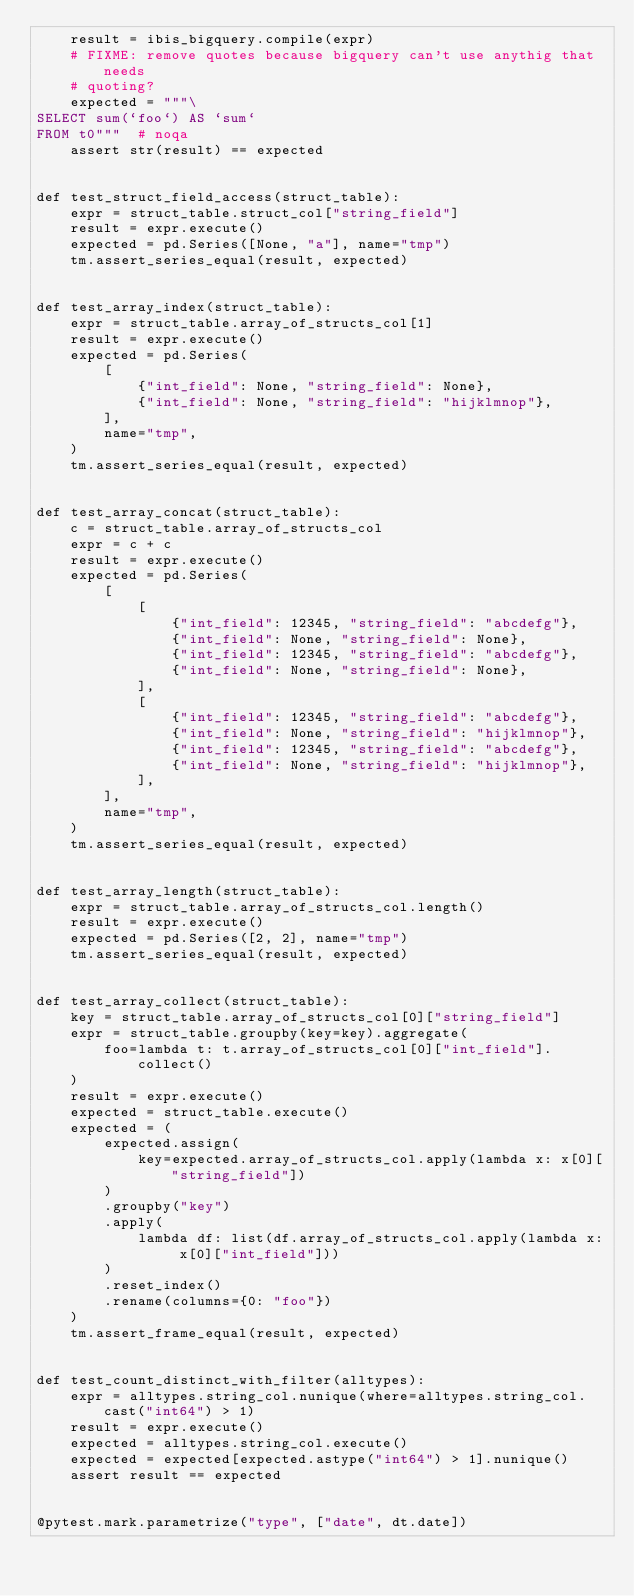Convert code to text. <code><loc_0><loc_0><loc_500><loc_500><_Python_>    result = ibis_bigquery.compile(expr)
    # FIXME: remove quotes because bigquery can't use anythig that needs
    # quoting?
    expected = """\
SELECT sum(`foo`) AS `sum`
FROM t0"""  # noqa
    assert str(result) == expected


def test_struct_field_access(struct_table):
    expr = struct_table.struct_col["string_field"]
    result = expr.execute()
    expected = pd.Series([None, "a"], name="tmp")
    tm.assert_series_equal(result, expected)


def test_array_index(struct_table):
    expr = struct_table.array_of_structs_col[1]
    result = expr.execute()
    expected = pd.Series(
        [
            {"int_field": None, "string_field": None},
            {"int_field": None, "string_field": "hijklmnop"},
        ],
        name="tmp",
    )
    tm.assert_series_equal(result, expected)


def test_array_concat(struct_table):
    c = struct_table.array_of_structs_col
    expr = c + c
    result = expr.execute()
    expected = pd.Series(
        [
            [
                {"int_field": 12345, "string_field": "abcdefg"},
                {"int_field": None, "string_field": None},
                {"int_field": 12345, "string_field": "abcdefg"},
                {"int_field": None, "string_field": None},
            ],
            [
                {"int_field": 12345, "string_field": "abcdefg"},
                {"int_field": None, "string_field": "hijklmnop"},
                {"int_field": 12345, "string_field": "abcdefg"},
                {"int_field": None, "string_field": "hijklmnop"},
            ],
        ],
        name="tmp",
    )
    tm.assert_series_equal(result, expected)


def test_array_length(struct_table):
    expr = struct_table.array_of_structs_col.length()
    result = expr.execute()
    expected = pd.Series([2, 2], name="tmp")
    tm.assert_series_equal(result, expected)


def test_array_collect(struct_table):
    key = struct_table.array_of_structs_col[0]["string_field"]
    expr = struct_table.groupby(key=key).aggregate(
        foo=lambda t: t.array_of_structs_col[0]["int_field"].collect()
    )
    result = expr.execute()
    expected = struct_table.execute()
    expected = (
        expected.assign(
            key=expected.array_of_structs_col.apply(lambda x: x[0]["string_field"])
        )
        .groupby("key")
        .apply(
            lambda df: list(df.array_of_structs_col.apply(lambda x: x[0]["int_field"]))
        )
        .reset_index()
        .rename(columns={0: "foo"})
    )
    tm.assert_frame_equal(result, expected)


def test_count_distinct_with_filter(alltypes):
    expr = alltypes.string_col.nunique(where=alltypes.string_col.cast("int64") > 1)
    result = expr.execute()
    expected = alltypes.string_col.execute()
    expected = expected[expected.astype("int64") > 1].nunique()
    assert result == expected


@pytest.mark.parametrize("type", ["date", dt.date])</code> 